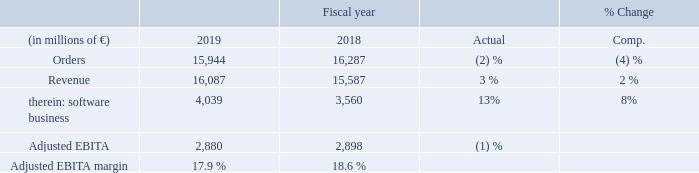Orders for Digital Industries declined due to lower demand in the short-cycle factory automation and motion control businesses, which faced increasingly adverse market conditions during the course of the fiscal year, particularly in the automotive and machine building industries. These declines were only partly offset by clear growth in the process automation business and a moderate increase in the software business, which was due to positive currency translation effects and new volume from recent acquisitions, particularly including Mendix.
The latter two businesses were also the drivers for revenue growth, as year-overyear revenue growth for the short-cycle businesses in the first half of fiscal 2019 gave way to declines in the second half. On a geographic basis, orders declined in the regions Europe, C. I. S., Africa, Middle East and in the Americas, only partly offset by an increase in the Asia, Australia region. Revenue rose in all three reporting regions. The software business strengthened its contribution to Adjusted EBITA with a double-digit increase.
Higher expenses related to new cloud-based offerings were partly offset by a € 50 million gain from the sale of an equity investment. The process automation business showed a moderate increase in Adjusted EBITA, due mainly to higher revenue. Nevertheless, Adjusted EBITA for Digital Industries overall came in slightly lower year-over-year due to clear declines in the short-cycle businesses. Severance charges were € 92 million in fiscal 2019, up from € 75 million a year earlier. Digital Industries’ order backlog was € 5 billion at the end of the fiscal year, of which € 4 billion are expected to be converted into revenue in fiscal 2020.
Digital Industries achieved its results in a market environment that lost momentum in the course of fiscal 2019. In particular, demand for investment goods eroded notably in the second half of the fiscal year. All regions were impacted by the slowdown, and countries with strong focus on investment goods and strong export ties to China suffered notably. While process industries still benefited from positive development of raw material prices, discrete industries faced headwinds from low demand including destocking effects. The automotive industry was hit by production cuts in Europe and weak demand in China. This, among other factors, also impacted the machine building industry, particularly affecting customers in Germany and Japan.
Production
growth in the pharmaceutical and chemicals industries flattened
during the course of fiscal 2019, due in part to spillover effects from the automotive industry on related chemicals segments. The food and beverage industry grew modestly and global electronics and semiconductor production expanded but prices were under pressure. For fiscal 2020, the market environment for Digital Industries is expected to weaken further. Manufacturing investments are expected to decrease at least moderately but then begin to stabilize in the second half of fiscal 2020. An overall decline in investment sentiment caused by global trade tensions, among other factors, dampens short-term expectations and fuels increasing cautiousness for investments globally. A weakening of growth in China could lead to spillover effects in other Asian
countries and also in Europe.
What was the rationale for decline in the orders for digital industries? Due to lower demand in the short-cycle factory automation and motion control businesses, which faced increasingly adverse market conditions during the course of the fiscal year, particularly in the automotive and machine building industries. What was the severance charge in 2019? Severance charges were € 92 million in fiscal 2019. What was the impact of positive development of raw material prices on discrete industries? Discrete industries faced headwinds from low demand including destocking effects. What was the average revenue in 2019 and 2018?
Answer scale should be: million. (16,087 + 15,587) / 2
Answer: 15837. What is the increase / (decrease) in the Adjusted EBITDA margin from 2018 to 2019?
Answer scale should be: percent. 17.9% - 18.6%
Answer: -0.7. What percentage of revenue is software business comprised of in 2019?
Answer scale should be: percent. 4,039 / 16,087
Answer: 25.11. 